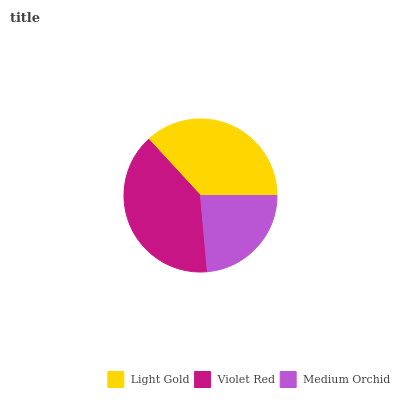Is Medium Orchid the minimum?
Answer yes or no. Yes. Is Violet Red the maximum?
Answer yes or no. Yes. Is Violet Red the minimum?
Answer yes or no. No. Is Medium Orchid the maximum?
Answer yes or no. No. Is Violet Red greater than Medium Orchid?
Answer yes or no. Yes. Is Medium Orchid less than Violet Red?
Answer yes or no. Yes. Is Medium Orchid greater than Violet Red?
Answer yes or no. No. Is Violet Red less than Medium Orchid?
Answer yes or no. No. Is Light Gold the high median?
Answer yes or no. Yes. Is Light Gold the low median?
Answer yes or no. Yes. Is Violet Red the high median?
Answer yes or no. No. Is Medium Orchid the low median?
Answer yes or no. No. 